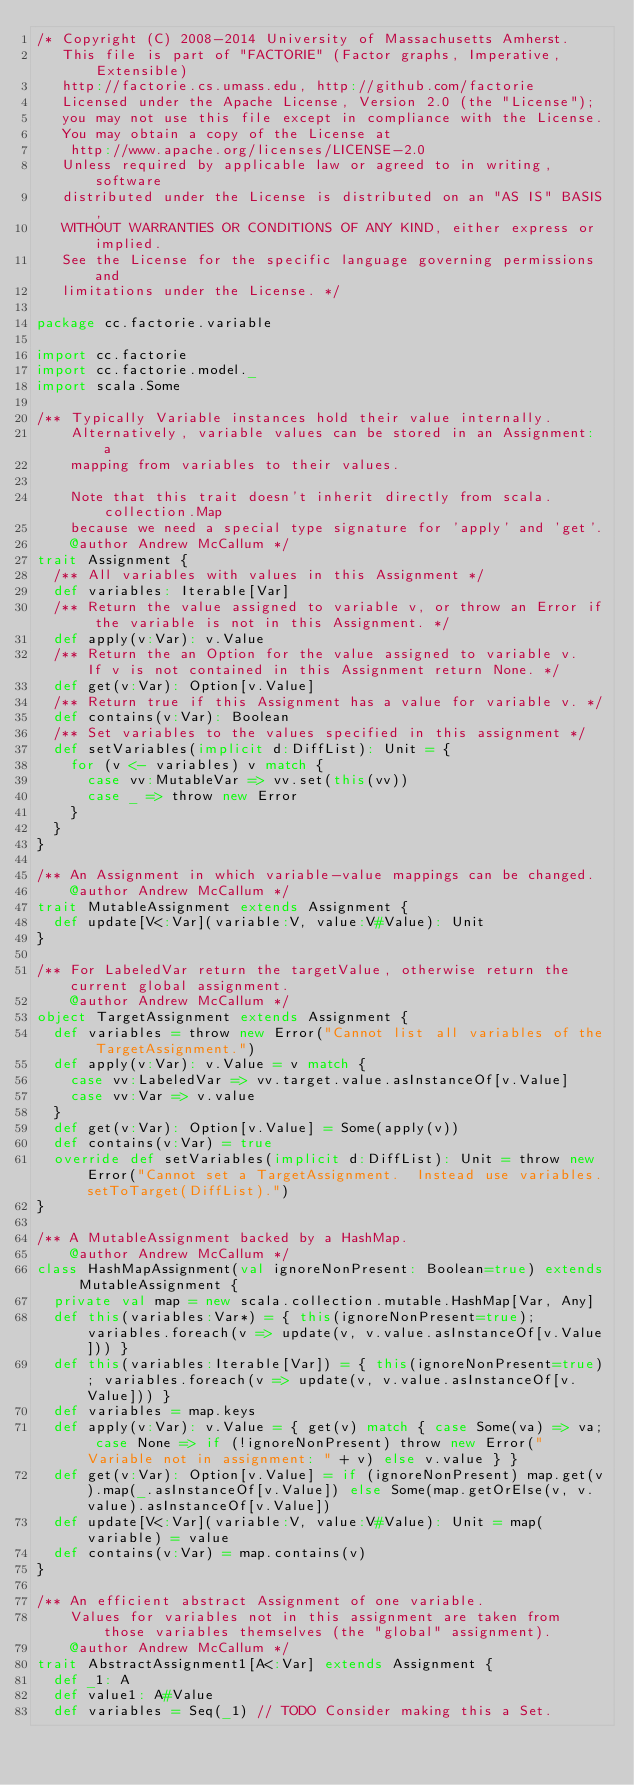Convert code to text. <code><loc_0><loc_0><loc_500><loc_500><_Scala_>/* Copyright (C) 2008-2014 University of Massachusetts Amherst.
   This file is part of "FACTORIE" (Factor graphs, Imperative, Extensible)
   http://factorie.cs.umass.edu, http://github.com/factorie
   Licensed under the Apache License, Version 2.0 (the "License");
   you may not use this file except in compliance with the License.
   You may obtain a copy of the License at
    http://www.apache.org/licenses/LICENSE-2.0
   Unless required by applicable law or agreed to in writing, software
   distributed under the License is distributed on an "AS IS" BASIS,
   WITHOUT WARRANTIES OR CONDITIONS OF ANY KIND, either express or implied.
   See the License for the specific language governing permissions and
   limitations under the License. */

package cc.factorie.variable

import cc.factorie
import cc.factorie.model._
import scala.Some

/** Typically Variable instances hold their value internally.
    Alternatively, variable values can be stored in an Assignment: a
    mapping from variables to their values.
    
    Note that this trait doesn't inherit directly from scala.collection.Map
    because we need a special type signature for 'apply' and 'get'.
    @author Andrew McCallum */
trait Assignment {
  /** All variables with values in this Assignment */
  def variables: Iterable[Var]
  /** Return the value assigned to variable v, or throw an Error if the variable is not in this Assignment. */
  def apply(v:Var): v.Value
  /** Return the an Option for the value assigned to variable v.  If v is not contained in this Assignment return None. */
  def get(v:Var): Option[v.Value]
  /** Return true if this Assignment has a value for variable v. */
  def contains(v:Var): Boolean
  /** Set variables to the values specified in this assignment */
  def setVariables(implicit d:DiffList): Unit = {
    for (v <- variables) v match {
      case vv:MutableVar => vv.set(this(vv))
      case _ => throw new Error
    }
  }
}

/** An Assignment in which variable-value mappings can be changed.
    @author Andrew McCallum */
trait MutableAssignment extends Assignment {
  def update[V<:Var](variable:V, value:V#Value): Unit
}

/** For LabeledVar return the targetValue, otherwise return the current global assignment.
    @author Andrew McCallum */
object TargetAssignment extends Assignment {
  def variables = throw new Error("Cannot list all variables of the TargetAssignment.")
  def apply(v:Var): v.Value = v match {
    case vv:LabeledVar => vv.target.value.asInstanceOf[v.Value]
    case vv:Var => v.value
  }
  def get(v:Var): Option[v.Value] = Some(apply(v))
  def contains(v:Var) = true
  override def setVariables(implicit d:DiffList): Unit = throw new Error("Cannot set a TargetAssignment.  Instead use variables.setToTarget(DiffList).")
}

/** A MutableAssignment backed by a HashMap.
    @author Andrew McCallum */
class HashMapAssignment(val ignoreNonPresent: Boolean=true) extends MutableAssignment {
  private val map = new scala.collection.mutable.HashMap[Var, Any]
  def this(variables:Var*) = { this(ignoreNonPresent=true); variables.foreach(v => update(v, v.value.asInstanceOf[v.Value])) }
  def this(variables:Iterable[Var]) = { this(ignoreNonPresent=true); variables.foreach(v => update(v, v.value.asInstanceOf[v.Value])) }
  def variables = map.keys
  def apply(v:Var): v.Value = { get(v) match { case Some(va) => va; case None => if (!ignoreNonPresent) throw new Error("Variable not in assignment: " + v) else v.value } }
  def get(v:Var): Option[v.Value] = if (ignoreNonPresent) map.get(v).map(_.asInstanceOf[v.Value]) else Some(map.getOrElse(v, v.value).asInstanceOf[v.Value])
  def update[V<:Var](variable:V, value:V#Value): Unit = map(variable) = value
  def contains(v:Var) = map.contains(v)
}

/** An efficient abstract Assignment of one variable.
    Values for variables not in this assignment are taken from those variables themselves (the "global" assignment).
    @author Andrew McCallum */
trait AbstractAssignment1[A<:Var] extends Assignment {
  def _1: A
  def value1: A#Value
  def variables = Seq(_1) // TODO Consider making this a Set.</code> 